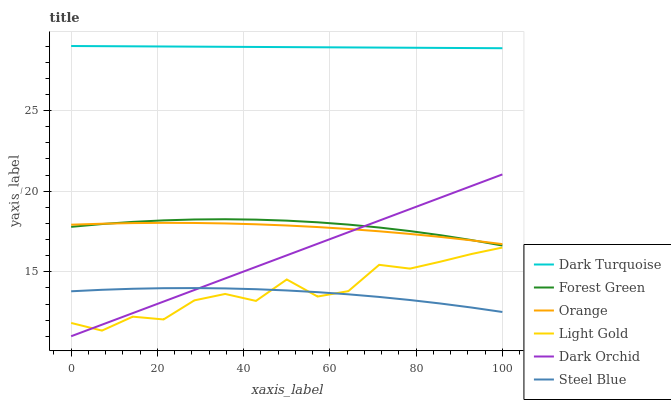Does Steel Blue have the minimum area under the curve?
Answer yes or no. Yes. Does Dark Turquoise have the maximum area under the curve?
Answer yes or no. Yes. Does Dark Orchid have the minimum area under the curve?
Answer yes or no. No. Does Dark Orchid have the maximum area under the curve?
Answer yes or no. No. Is Dark Orchid the smoothest?
Answer yes or no. Yes. Is Light Gold the roughest?
Answer yes or no. Yes. Is Steel Blue the smoothest?
Answer yes or no. No. Is Steel Blue the roughest?
Answer yes or no. No. Does Dark Orchid have the lowest value?
Answer yes or no. Yes. Does Steel Blue have the lowest value?
Answer yes or no. No. Does Dark Turquoise have the highest value?
Answer yes or no. Yes. Does Dark Orchid have the highest value?
Answer yes or no. No. Is Orange less than Dark Turquoise?
Answer yes or no. Yes. Is Orange greater than Light Gold?
Answer yes or no. Yes. Does Forest Green intersect Dark Orchid?
Answer yes or no. Yes. Is Forest Green less than Dark Orchid?
Answer yes or no. No. Is Forest Green greater than Dark Orchid?
Answer yes or no. No. Does Orange intersect Dark Turquoise?
Answer yes or no. No. 